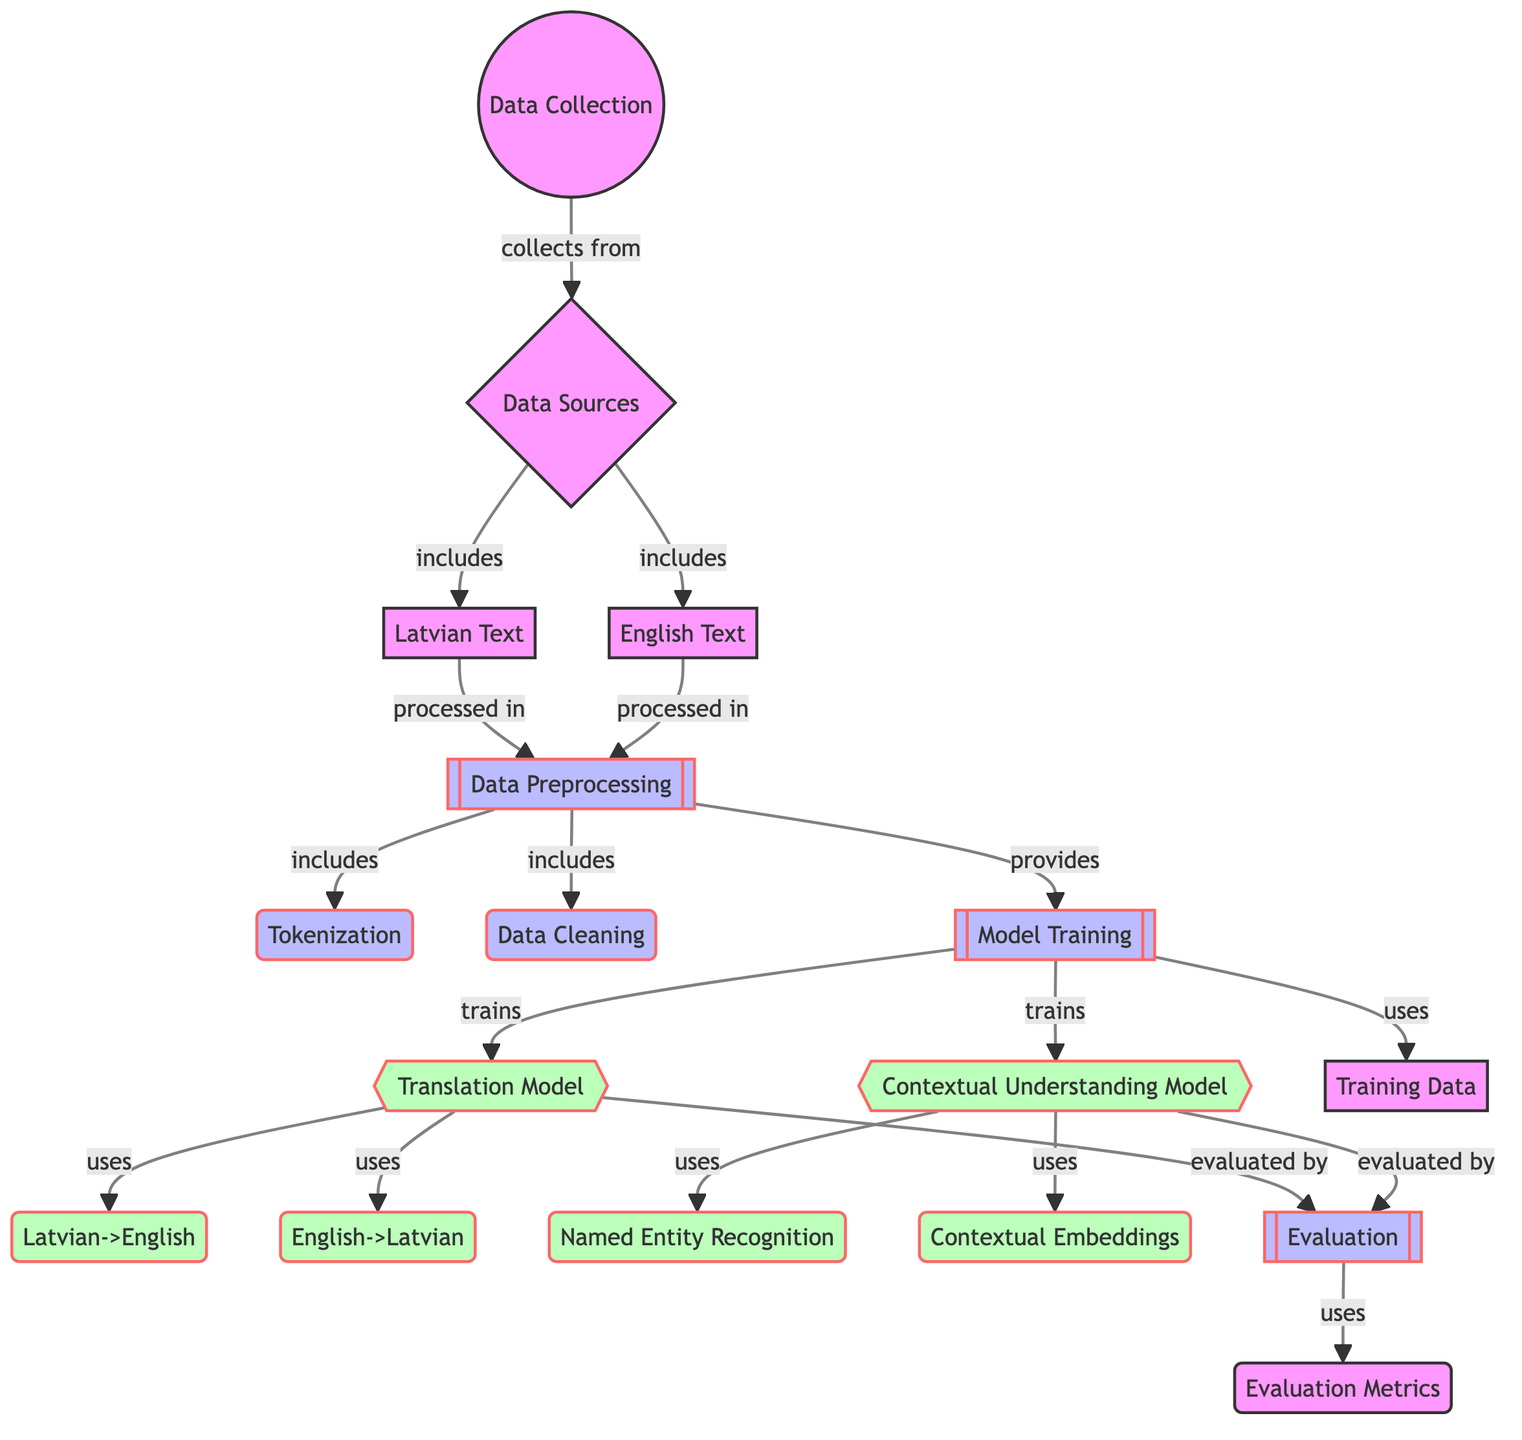What is the first node in the diagram? The first node is "Data Collection," indicating the initial step of gathering information necessary for the entire process.
Answer: Data Collection How many types of data sources are represented in the diagram? There are two main types of data sources: "Latvian Text" and "English Text," which are the specific linguistic inputs for the models.
Answer: Two What is the purpose of the Data Preprocessing node? The Data Preprocessing node prepares the collected data for further steps by including processes like Tokenization and Cleaning, which refine the data for model training.
Answer: To prepare data Which model is used for translating Latvian to English? The model responsible for this translation is referred to as "Latvian->English," specifically designed to convert text from Latvian to English.
Answer: Latvian->English What follows the Model Training in the process? The step that follows Model Training is Evaluation, where the performance of both models is assessed based on specified metrics to ensure accuracy.
Answer: Evaluation How many models are used in the contextual understanding phase? There are two models involved in the contextual understanding phase: "Named Entity Recognition" and "Contextual Embeddings." These models aid in grasping the context of the translated text.
Answer: Two What type of evaluations are done after model training? The evaluations involve using "Evaluation Metrics" to measure how well the models perform in tasks such as translation accuracy and contextual understanding.
Answer: Evaluation Metrics What provides input to the Model Training node? The input to the Model Training node comes from Data Preprocessing, which supplies the refined output necessary for the training phase of both translation and understanding models.
Answer: Data Preprocessing From which nodes does the context understanding model take input? The context understanding model takes input from "Named Entity Recognition" and "Contextual Embeddings," both of which contribute to understanding the context in translations.
Answer: Named Entity Recognition and Contextual Embeddings What are the two main outputs for the translation models in the diagram? The two main outputs are "Latvian->English" and "English->Latvian," indicating the bilingual translation capabilities of the system in both directions.
Answer: Latvian->English and English->Latvian 